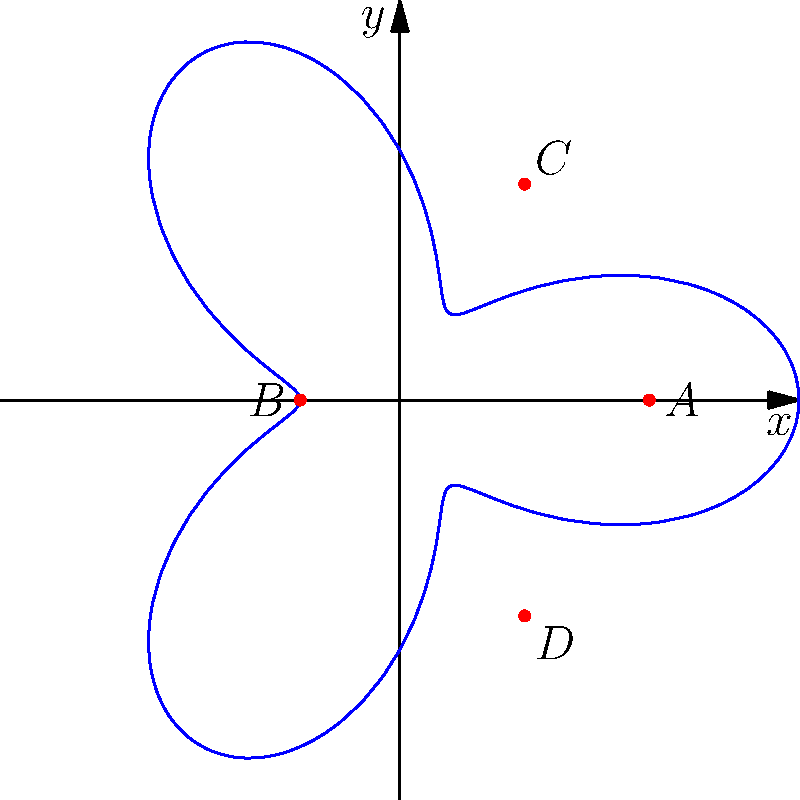As a fine-art photographer, you're planning to capture the city skyline from various angles. The optimal camera positions form a curve in polar coordinates given by the equation $r = 5 + 3\cos(3\theta)$. Points A, B, C, and D represent specific locations on this curve. If you want to maximize the variety in your shots, which two points should you choose for your photography sessions that are farthest apart? To find the two points that are farthest apart, we need to calculate the distances between all pairs of points and compare them. Let's go through this step-by-step:

1) First, we need to identify the coordinates of each point. From the graph:
   A: $(5, 0)$
   B: $(-2, 0)$
   C: $(2.5, 4.33)$
   D: $(2.5, -4.33)$

2) Now, we'll calculate the distance between each pair of points using the distance formula: $d = \sqrt{(x_2-x_1)^2 + (y_2-y_1)^2}$

3) AB distance:
   $d_{AB} = \sqrt{(-2-5)^2 + (0-0)^2} = \sqrt{49} = 7$

4) AC distance:
   $d_{AC} = \sqrt{(2.5-5)^2 + (4.33-0)^2} = \sqrt{6.25 + 18.75} = \sqrt{25} = 5$

5) AD distance:
   $d_{AD} = \sqrt{(2.5-5)^2 + (-4.33-0)^2} = \sqrt{6.25 + 18.75} = \sqrt{25} = 5$

6) BC distance:
   $d_{BC} = \sqrt{(2.5-(-2))^2 + (4.33-0)^2} = \sqrt{20.25 + 18.75} = \sqrt{39} \approx 6.24$

7) BD distance:
   $d_{BD} = \sqrt{(2.5-(-2))^2 + (-4.33-0)^2} = \sqrt{20.25 + 18.75} = \sqrt{39} \approx 6.24$

8) CD distance:
   $d_{CD} = \sqrt{(2.5-2.5)^2 + (-4.33-4.33)^2} = \sqrt{0 + 75.11} = \sqrt{75.11} \approx 8.67$

9) The largest distance is between points C and D, which is approximately 8.67 units apart.

Therefore, to maximize the variety in your shots, you should choose points C and D for your photography sessions.
Answer: Points C and D 